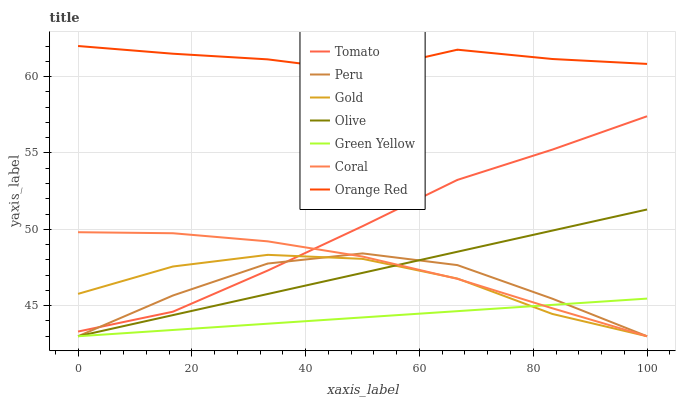Does Green Yellow have the minimum area under the curve?
Answer yes or no. Yes. Does Orange Red have the maximum area under the curve?
Answer yes or no. Yes. Does Gold have the minimum area under the curve?
Answer yes or no. No. Does Gold have the maximum area under the curve?
Answer yes or no. No. Is Olive the smoothest?
Answer yes or no. Yes. Is Peru the roughest?
Answer yes or no. Yes. Is Gold the smoothest?
Answer yes or no. No. Is Gold the roughest?
Answer yes or no. No. Does Gold have the lowest value?
Answer yes or no. Yes. Does Orange Red have the lowest value?
Answer yes or no. No. Does Orange Red have the highest value?
Answer yes or no. Yes. Does Gold have the highest value?
Answer yes or no. No. Is Gold less than Orange Red?
Answer yes or no. Yes. Is Orange Red greater than Green Yellow?
Answer yes or no. Yes. Does Olive intersect Coral?
Answer yes or no. Yes. Is Olive less than Coral?
Answer yes or no. No. Is Olive greater than Coral?
Answer yes or no. No. Does Gold intersect Orange Red?
Answer yes or no. No. 